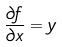<formula> <loc_0><loc_0><loc_500><loc_500>\frac { \partial f } { \partial x } = y</formula> 